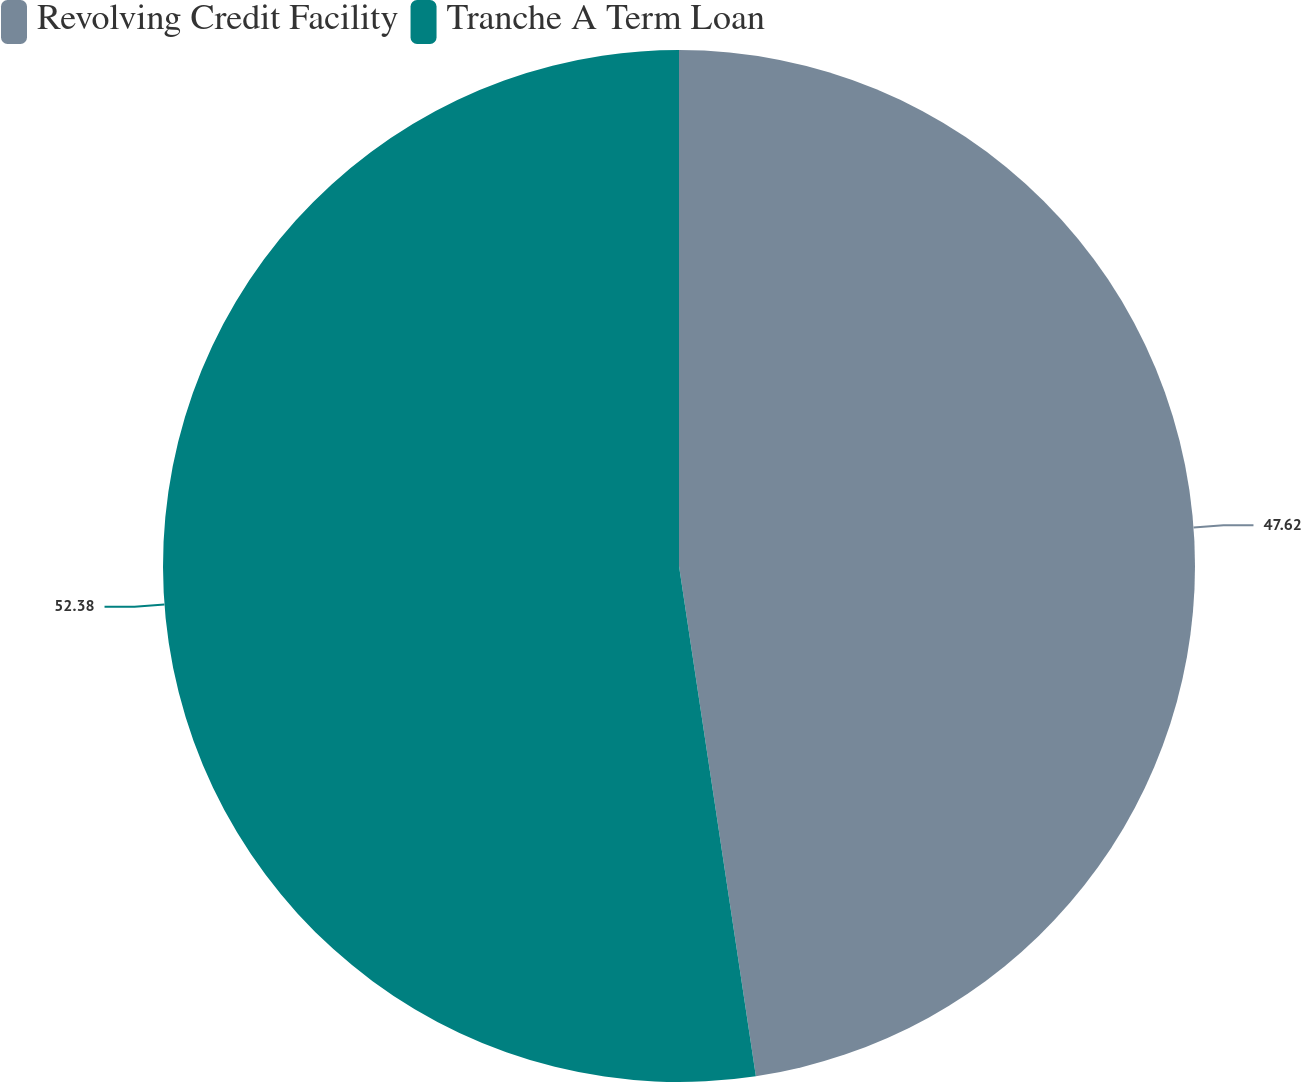<chart> <loc_0><loc_0><loc_500><loc_500><pie_chart><fcel>Revolving Credit Facility<fcel>Tranche A Term Loan<nl><fcel>47.62%<fcel>52.38%<nl></chart> 